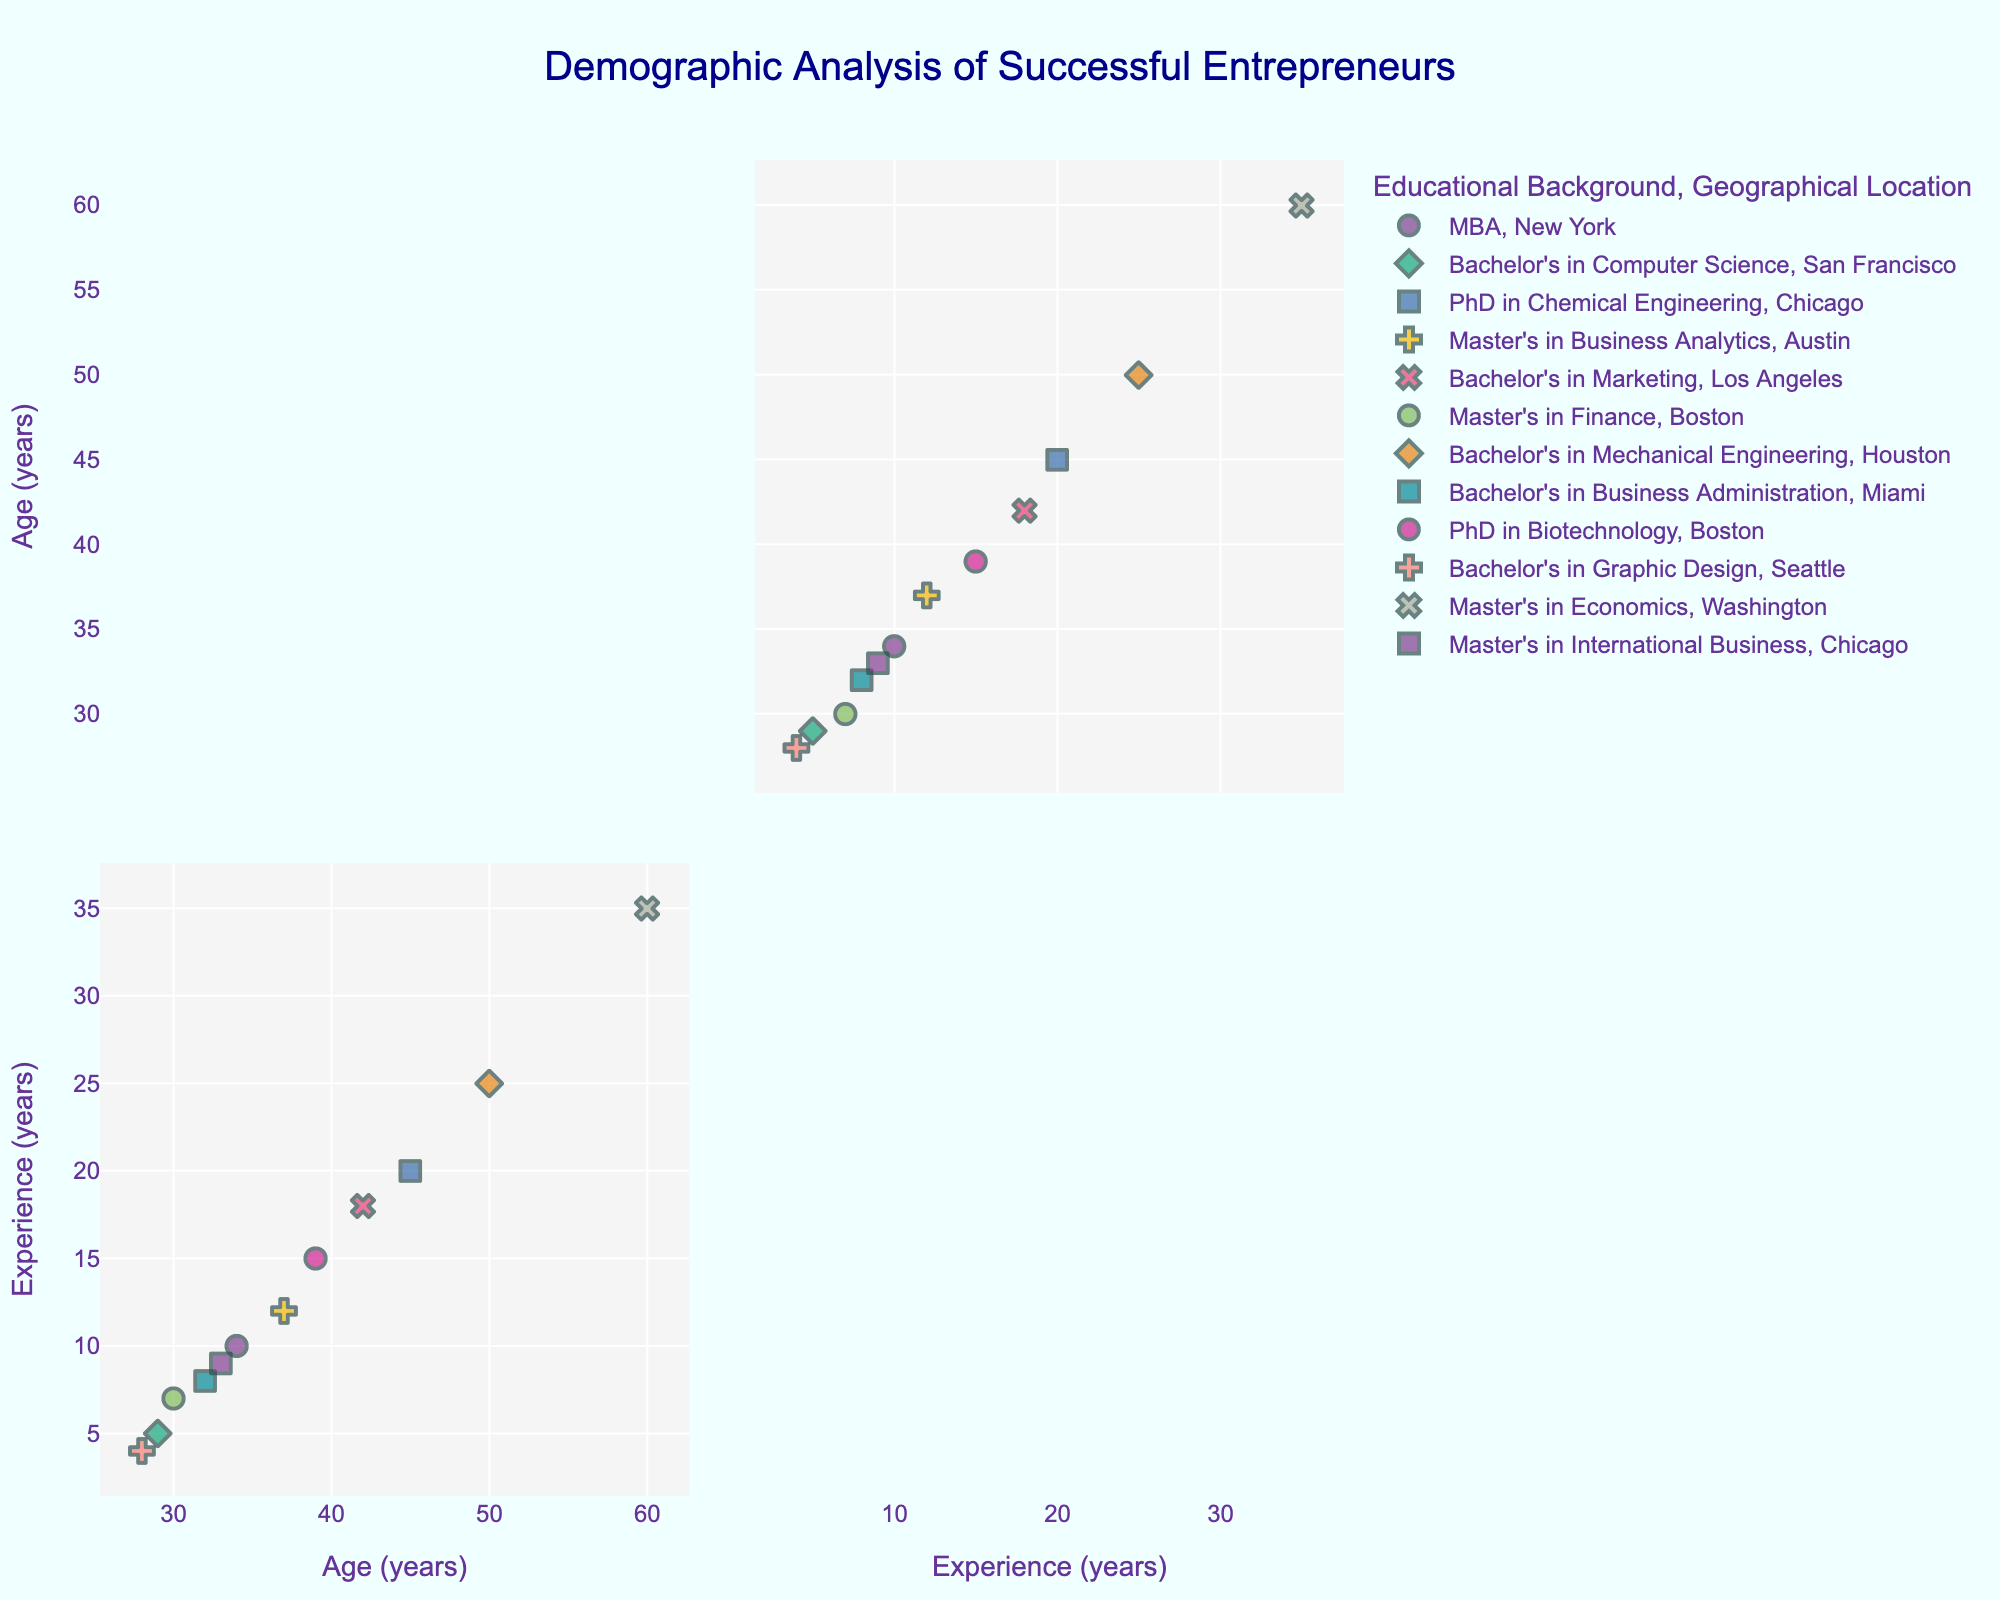What is the title of the figure? The title is typically located at the top of the figure and it gives an overview of what the plot represents. In this case, it should be clear and descriptive.
Answer: "Demographic Analysis of Successful Entrepreneurs" How many different educational backgrounds are represented? By looking at the color legend on the SPLOM, you can count the different categories/colors used to represent educational backgrounds.
Answer: 7 Which geographical location uses the 'cross' symbol in the plot? The figure legend shows symbols associated with each geographical location. Finding the symbol 'cross' in the legend will indicate the geographical location it represents.
Answer: Seattle Who has the maximum industry experience among the successful entrepreneurs? Locate the point that is furthest right on the plot for 'Industry Experience' dimension. From the data, we can identify the corresponding individual.
Answer: David Garcia What is the mean age of the entrepreneurs located in Boston? Identify the age values for all data points labeled with 'Boston' in the legend, then calculate the average of these values.
Answer: The mean age is (30 + 39) / 2 = 34.5 What age group has the most diverse educational background? Assess the scatter plot and identify which age range contains points of the most varied colors, indicating a diverse educational background.
Answer: 32-39 Is there a correlation between age and industry experience? By examining the scatter plot between 'Age' and 'Industry Experience', one can observe the pattern or trend to infer correlation. A positive correlation would show an upward trend.
Answer: Yes, there is a positive correlation Which individual has a PhD in Biotechnology and what is their geographical location? Locate the point color-coded for 'PhD in Biotechnology' and check the symbol to identify the geographical location. Refer to the data to find the corresponding name.
Answer: James Anderson, located in Boston Who is the youngest entrepreneur with a Master's degree and what is their industry experience? From the master’s degree color, find the lowest age value and then check the industry experience for that individual.
Answer: Jessica Wilson, 7 years 